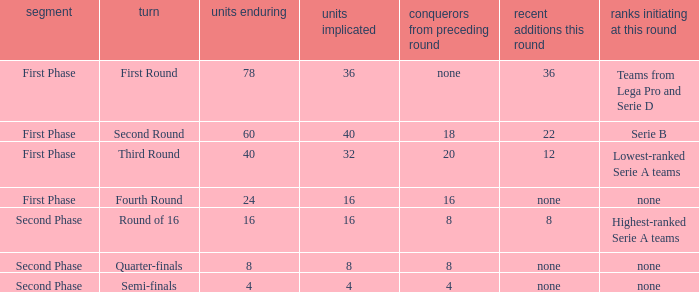Would you mind parsing the complete table? {'header': ['segment', 'turn', 'units enduring', 'units implicated', 'conquerors from preceding round', 'recent additions this round', 'ranks initiating at this round'], 'rows': [['First Phase', 'First Round', '78', '36', 'none', '36', 'Teams from Lega Pro and Serie D'], ['First Phase', 'Second Round', '60', '40', '18', '22', 'Serie B'], ['First Phase', 'Third Round', '40', '32', '20', '12', 'Lowest-ranked Serie A teams'], ['First Phase', 'Fourth Round', '24', '16', '16', 'none', 'none'], ['Second Phase', 'Round of 16', '16', '16', '8', '8', 'Highest-ranked Serie A teams'], ['Second Phase', 'Quarter-finals', '8', '8', '8', 'none', 'none'], ['Second Phase', 'Semi-finals', '4', '4', '4', 'none', 'none']]} The new entries this round was shown to be 12, in which phase would you find this? First Phase. 